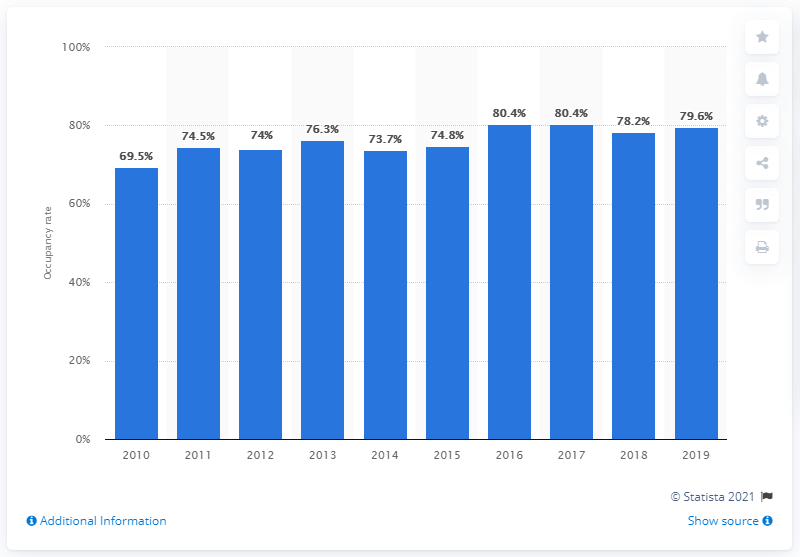Point out several critical features in this image. In 2017, the occupancy rate of hotels in Ibiza was 80.4%. In 2018, the occupancy rate of hotels in Ibiza was 80.4%. 